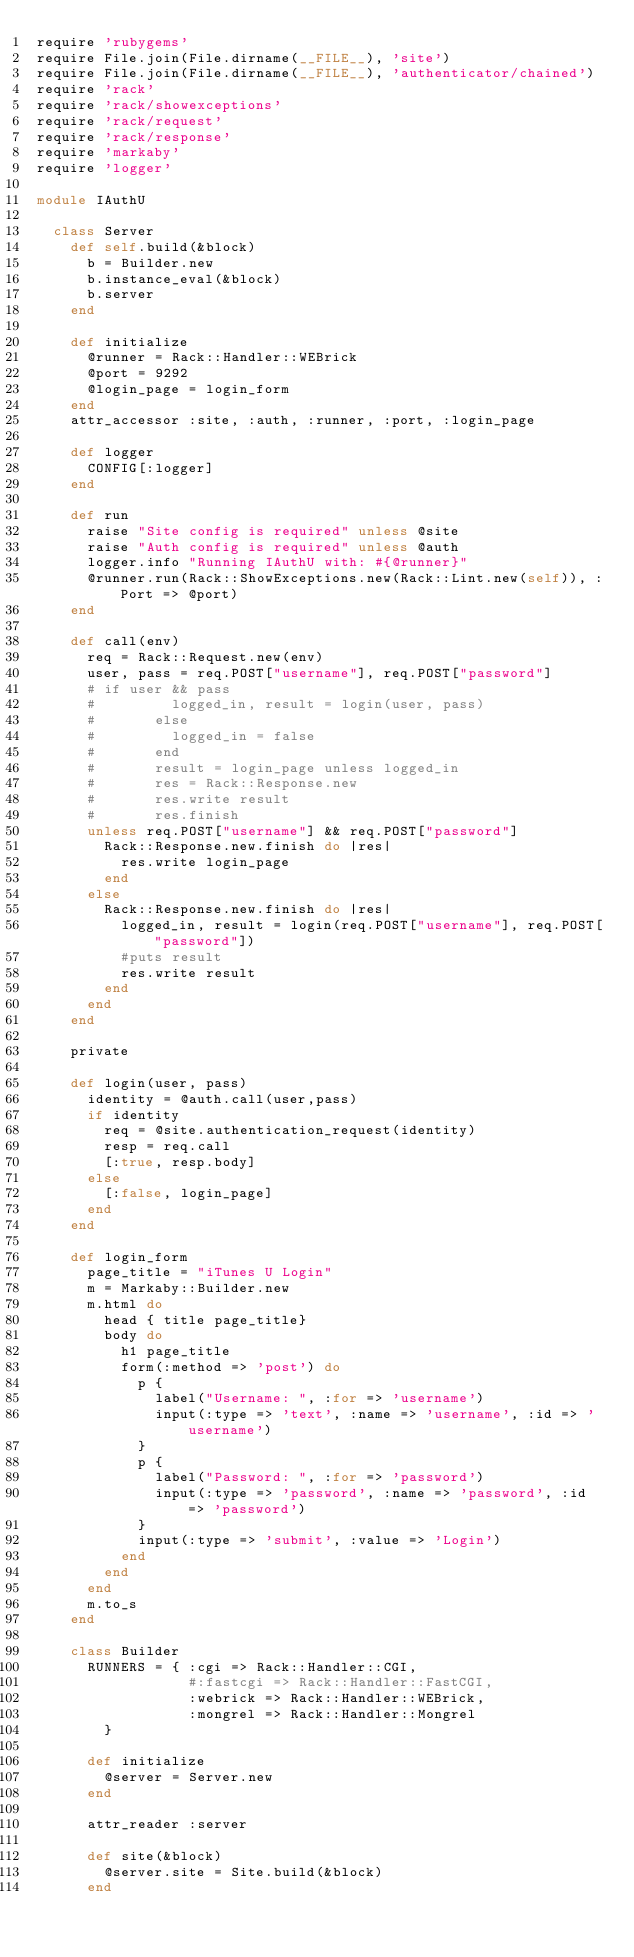<code> <loc_0><loc_0><loc_500><loc_500><_Ruby_>require 'rubygems'
require File.join(File.dirname(__FILE__), 'site')
require File.join(File.dirname(__FILE__), 'authenticator/chained')
require 'rack'
require 'rack/showexceptions'
require 'rack/request'
require 'rack/response'
require 'markaby'
require 'logger'

module IAuthU
  
  class Server
    def self.build(&block)
      b = Builder.new
      b.instance_eval(&block)
      b.server
    end
    
    def initialize
      @runner = Rack::Handler::WEBrick
      @port = 9292
      @login_page = login_form
    end
    attr_accessor :site, :auth, :runner, :port, :login_page
    
    def logger
      CONFIG[:logger]
    end
    
    def run
      raise "Site config is required" unless @site
      raise "Auth config is required" unless @auth
      logger.info "Running IAuthU with: #{@runner}"
      @runner.run(Rack::ShowExceptions.new(Rack::Lint.new(self)), :Port => @port)
    end
    
    def call(env)
      req = Rack::Request.new(env)
      user, pass = req.POST["username"], req.POST["password"]
      # if user && pass
      #         logged_in, result = login(user, pass)
      #       else
      #         logged_in = false
      #       end
      #       result = login_page unless logged_in
      #       res = Rack::Response.new
      #       res.write result
      #       res.finish
      unless req.POST["username"] && req.POST["password"]
        Rack::Response.new.finish do |res|
          res.write login_page
        end
      else
        Rack::Response.new.finish do |res|
          logged_in, result = login(req.POST["username"], req.POST["password"])
          #puts result
          res.write result
        end
      end
    end
    
    private
    
    def login(user, pass)
      identity = @auth.call(user,pass)
      if identity
        req = @site.authentication_request(identity)
        resp = req.call
        [:true, resp.body]
      else
        [:false, login_page]
      end
    end
    
    def login_form
      page_title = "iTunes U Login"
      m = Markaby::Builder.new
      m.html do
        head { title page_title}
        body do
          h1 page_title
          form(:method => 'post') do
            p {
              label("Username: ", :for => 'username')
              input(:type => 'text', :name => 'username', :id => 'username')
            }
            p {
              label("Password: ", :for => 'password')
              input(:type => 'password', :name => 'password', :id => 'password')
            }
            input(:type => 'submit', :value => 'Login')
          end
        end
      end
      m.to_s
    end
    
    class Builder
      RUNNERS = { :cgi => Rack::Handler::CGI,
                  #:fastcgi => Rack::Handler::FastCGI,
                  :webrick => Rack::Handler::WEBrick,
                  :mongrel => Rack::Handler::Mongrel
        }
        
      def initialize
        @server = Server.new
      end
      
      attr_reader :server
      
      def site(&block)
        @server.site = Site.build(&block)
      end
      </code> 